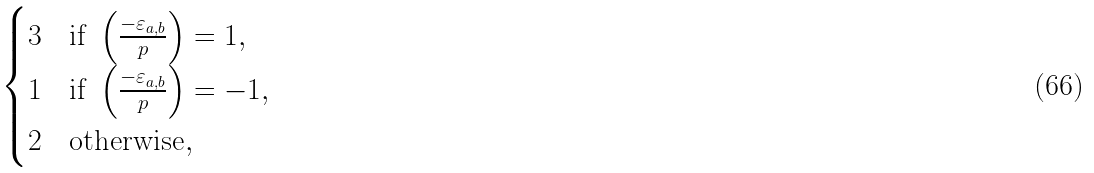Convert formula to latex. <formula><loc_0><loc_0><loc_500><loc_500>\begin{cases} 3 & \text {if } \left ( \frac { - \varepsilon _ { a , b } } { p } \right ) = 1 , \\ 1 & \text {if } \left ( \frac { - \varepsilon _ { a , b } } { p } \right ) = - 1 , \\ 2 & \text {otherwise} , \end{cases}</formula> 